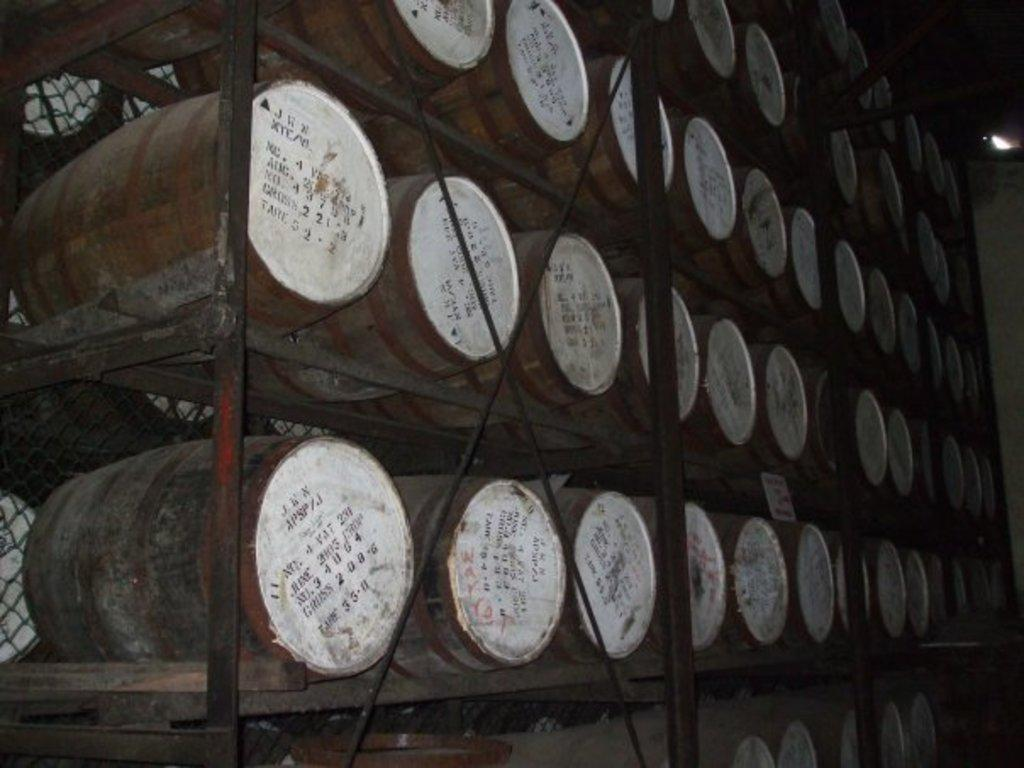What objects are present in the image? There are barrels in the image. How are the barrels arranged or organized? The barrels are on racks. Is there a beggar asking for money near the barrels in the image? There is no mention of a beggar in the image, so we cannot confirm or deny their presence. 